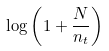Convert formula to latex. <formula><loc_0><loc_0><loc_500><loc_500>\log \left ( 1 + { \frac { N } { n _ { t } } } \right )</formula> 